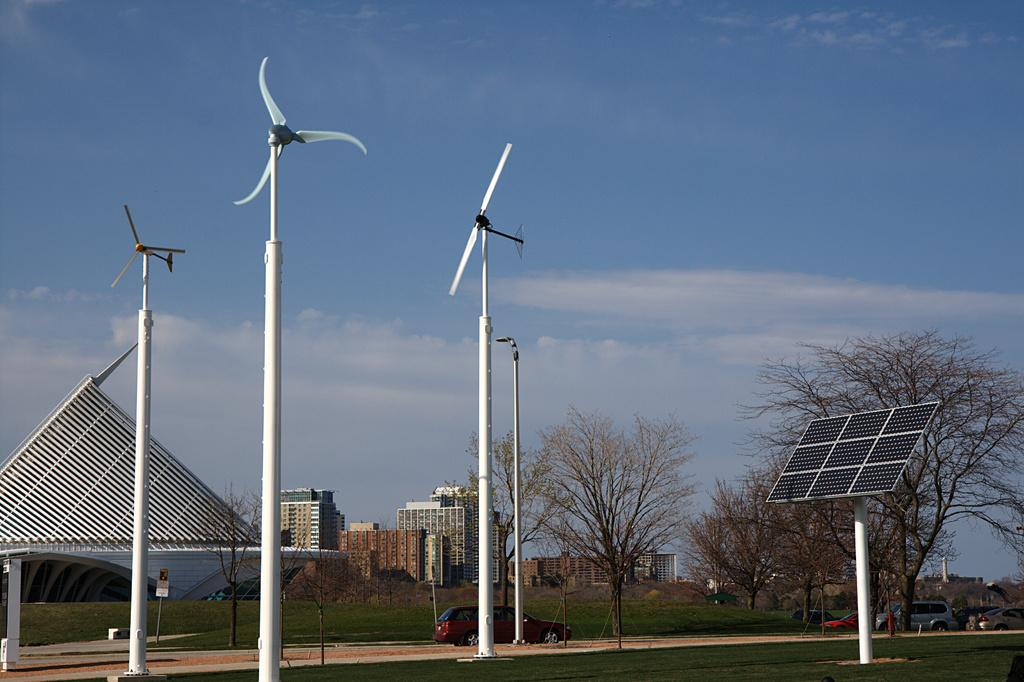What type of energy source is present in the image? There is a solar panel in the image, which is a source of solar energy. What other energy source can be seen in the image? There are windmills in the image, which generate wind energy. What type of structures are visible in the image? There are buildings in the image. What are the poles used for in the image? The poles in the image are likely used for supporting power lines or other infrastructure. What type of vegetation is present in the image? There are trees, plants, and grass in the image. What else can be seen in the image? There are vehicles in the image. What part of the natural environment is visible in the image? The sky is visible in the image. How many blades does the hen have in the image? There is no hen present in the image, so it is not possible to determine the number of blades it might have. 